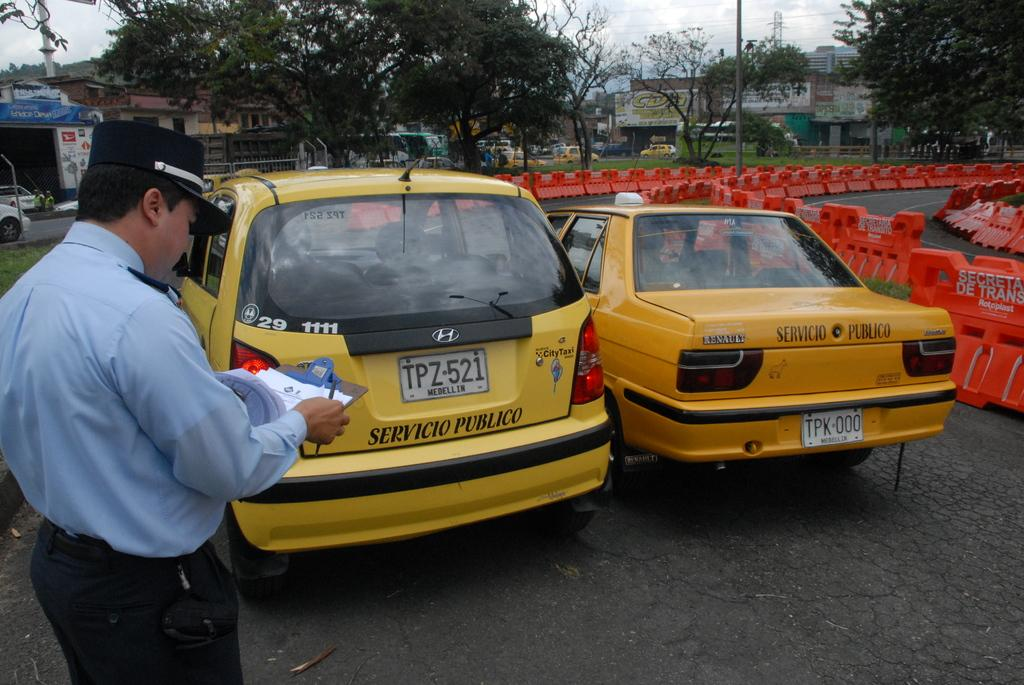<image>
Render a clear and concise summary of the photo. A man in a hat in front of parked cars, one that reads SERVICIO PUBLICO. 